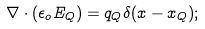Convert formula to latex. <formula><loc_0><loc_0><loc_500><loc_500>\nabla \cdot ( \epsilon _ { o } E _ { Q } ) = q _ { Q } \delta ( x - x _ { Q } ) ;</formula> 